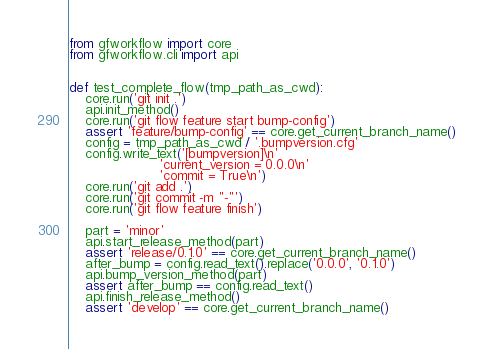Convert code to text. <code><loc_0><loc_0><loc_500><loc_500><_Python_>from gfworkflow import core
from gfworkflow.cli import api


def test_complete_flow(tmp_path_as_cwd):
    core.run('git init .')
    api.init_method()
    core.run('git flow feature start bump-config')
    assert 'feature/bump-config' == core.get_current_branch_name()
    config = tmp_path_as_cwd / '.bumpversion.cfg'
    config.write_text('[bumpversion]\n'
                      'current_version = 0.0.0\n'
                      'commit = True\n')
    core.run('git add .')
    core.run('git commit -m "-"')
    core.run('git flow feature finish')

    part = 'minor'
    api.start_release_method(part)
    assert 'release/0.1.0' == core.get_current_branch_name()
    after_bump = config.read_text().replace('0.0.0', '0.1.0')
    api.bump_version_method(part)
    assert after_bump == config.read_text()
    api.finish_release_method()
    assert 'develop' == core.get_current_branch_name()
</code> 